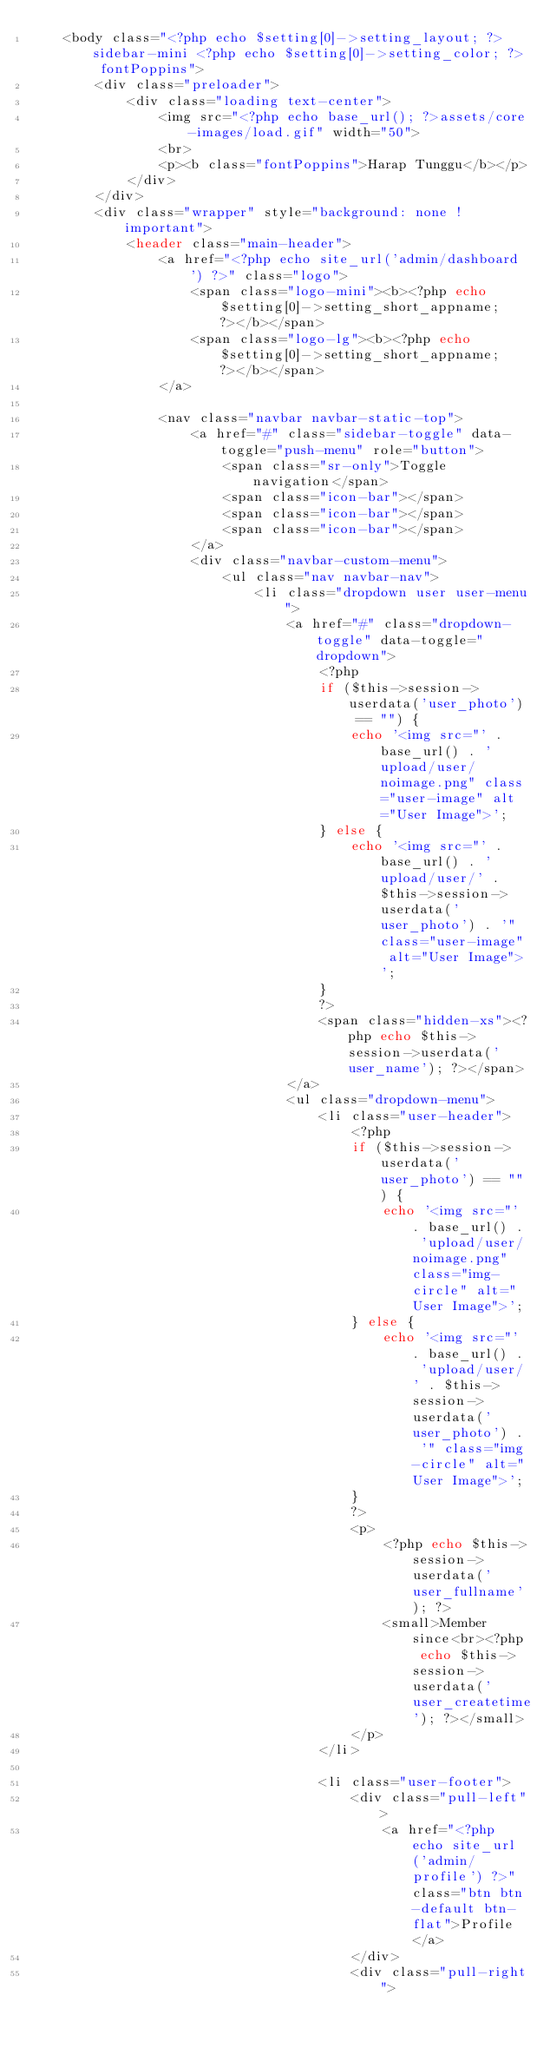Convert code to text. <code><loc_0><loc_0><loc_500><loc_500><_PHP_>    <body class="<?php echo $setting[0]->setting_layout; ?> sidebar-mini <?php echo $setting[0]->setting_color; ?> fontPoppins">
        <div class="preloader">
            <div class="loading text-center">
                <img src="<?php echo base_url(); ?>assets/core-images/load.gif" width="50">
                <br>
                <p><b class="fontPoppins">Harap Tunggu</b></p>
            </div>
        </div>
        <div class="wrapper" style="background: none !important">
            <header class="main-header">
                <a href="<?php echo site_url('admin/dashboard') ?>" class="logo">
                    <span class="logo-mini"><b><?php echo $setting[0]->setting_short_appname; ?></b></span>
                    <span class="logo-lg"><b><?php echo $setting[0]->setting_short_appname; ?></b></span>
                </a>

                <nav class="navbar navbar-static-top">
                    <a href="#" class="sidebar-toggle" data-toggle="push-menu" role="button">
                        <span class="sr-only">Toggle navigation</span>
                        <span class="icon-bar"></span>
                        <span class="icon-bar"></span>
                        <span class="icon-bar"></span>
                    </a>
                    <div class="navbar-custom-menu">
                        <ul class="nav navbar-nav">
                            <li class="dropdown user user-menu">
                                <a href="#" class="dropdown-toggle" data-toggle="dropdown">
                                    <?php
                                    if ($this->session->userdata('user_photo') == "") {
                                        echo '<img src="' . base_url() . 'upload/user/noimage.png" class="user-image" alt="User Image">';
                                    } else {
                                        echo '<img src="' . base_url() . 'upload/user/' . $this->session->userdata('user_photo') . '" class="user-image" alt="User Image">';
                                    }
                                    ?>
                                    <span class="hidden-xs"><?php echo $this->session->userdata('user_name'); ?></span>
                                </a>
                                <ul class="dropdown-menu">
                                    <li class="user-header">
                                        <?php
                                        if ($this->session->userdata('user_photo') == "") {
                                            echo '<img src="' . base_url() . 'upload/user/noimage.png" class="img-circle" alt="User Image">';
                                        } else {
                                            echo '<img src="' . base_url() . 'upload/user/' . $this->session->userdata('user_photo') . '" class="img-circle" alt="User Image">';
                                        }
                                        ?>
                                        <p>
                                            <?php echo $this->session->userdata('user_fullname'); ?>
                                            <small>Member since<br><?php echo $this->session->userdata('user_createtime'); ?></small>
                                        </p>
                                    </li>

                                    <li class="user-footer">
                                        <div class="pull-left">
                                            <a href="<?php echo site_url('admin/profile') ?>" class="btn btn-default btn-flat">Profile</a>
                                        </div>
                                        <div class="pull-right"></code> 